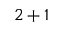<formula> <loc_0><loc_0><loc_500><loc_500>2 + 1</formula> 